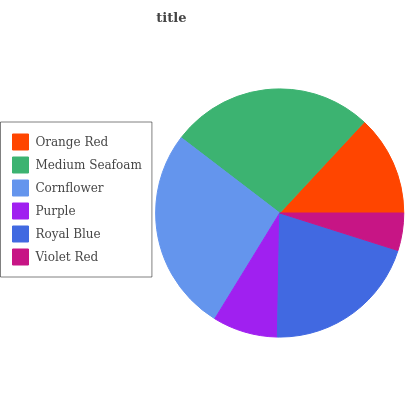Is Violet Red the minimum?
Answer yes or no. Yes. Is Cornflower the maximum?
Answer yes or no. Yes. Is Medium Seafoam the minimum?
Answer yes or no. No. Is Medium Seafoam the maximum?
Answer yes or no. No. Is Medium Seafoam greater than Orange Red?
Answer yes or no. Yes. Is Orange Red less than Medium Seafoam?
Answer yes or no. Yes. Is Orange Red greater than Medium Seafoam?
Answer yes or no. No. Is Medium Seafoam less than Orange Red?
Answer yes or no. No. Is Royal Blue the high median?
Answer yes or no. Yes. Is Orange Red the low median?
Answer yes or no. Yes. Is Cornflower the high median?
Answer yes or no. No. Is Cornflower the low median?
Answer yes or no. No. 